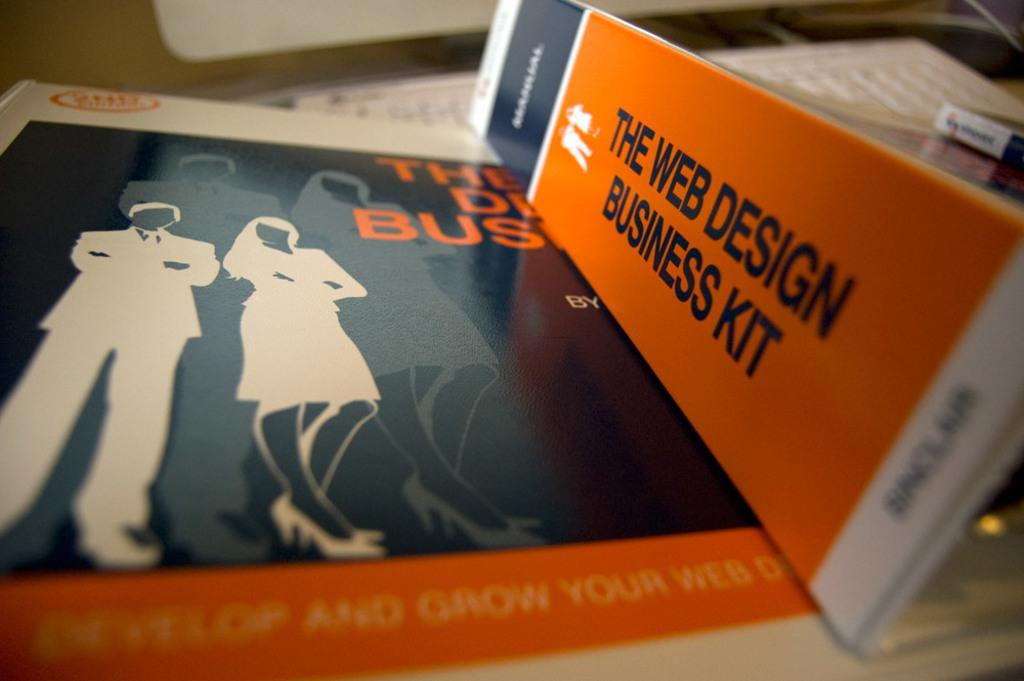Provide a one-sentence caption for the provided image. A couple of Web Design Business Kit binders are laying on a desk. 